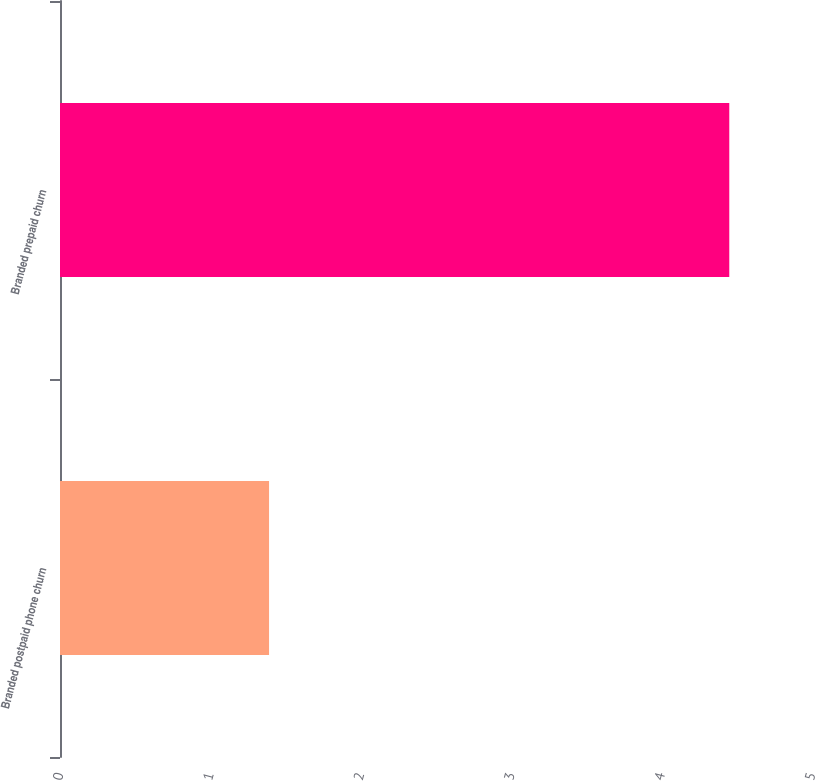<chart> <loc_0><loc_0><loc_500><loc_500><bar_chart><fcel>Branded postpaid phone churn<fcel>Branded prepaid churn<nl><fcel>1.39<fcel>4.45<nl></chart> 